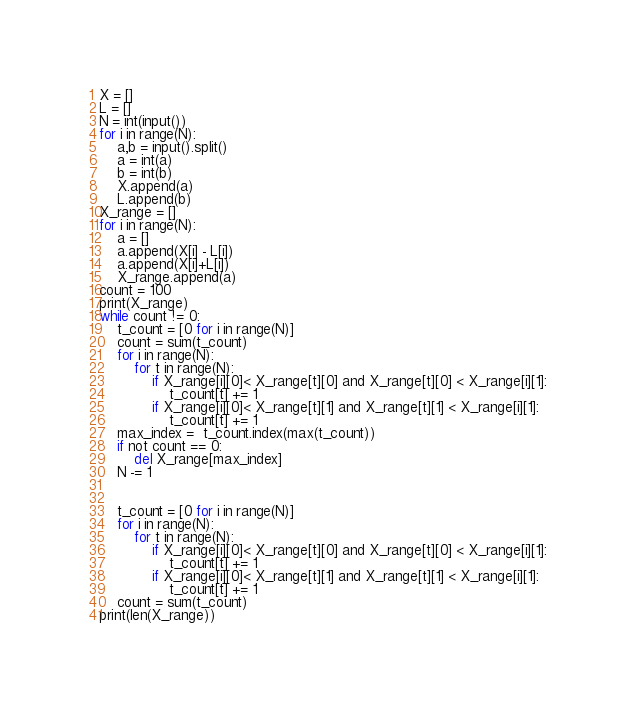<code> <loc_0><loc_0><loc_500><loc_500><_Python_>X = []
L = []
N = int(input())
for i in range(N):
    a,b = input().split()
    a = int(a)
    b = int(b)
    X.append(a)
    L.append(b)
X_range = []
for i in range(N):
    a = []
    a.append(X[i] - L[i])
    a.append(X[i]+L[i])
    X_range.append(a)
count = 100
print(X_range)
while count != 0:
    t_count = [0 for i in range(N)]
    count = sum(t_count)
    for i in range(N):
        for t in range(N):
            if X_range[i][0]< X_range[t][0] and X_range[t][0] < X_range[i][1]:
                t_count[t] += 1
            if X_range[i][0]< X_range[t][1] and X_range[t][1] < X_range[i][1]:
                t_count[t] += 1
    max_index =  t_count.index(max(t_count))
    if not count == 0:
        del X_range[max_index]
    N -= 1


    t_count = [0 for i in range(N)]
    for i in range(N):
        for t in range(N):
            if X_range[i][0]< X_range[t][0] and X_range[t][0] < X_range[i][1]:
                t_count[t] += 1
            if X_range[i][0]< X_range[t][1] and X_range[t][1] < X_range[i][1]:
                t_count[t] += 1
    count = sum(t_count)
print(len(X_range))</code> 